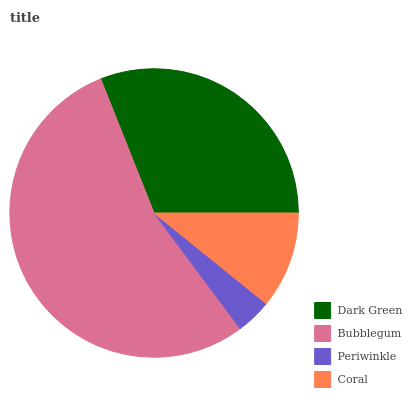Is Periwinkle the minimum?
Answer yes or no. Yes. Is Bubblegum the maximum?
Answer yes or no. Yes. Is Bubblegum the minimum?
Answer yes or no. No. Is Periwinkle the maximum?
Answer yes or no. No. Is Bubblegum greater than Periwinkle?
Answer yes or no. Yes. Is Periwinkle less than Bubblegum?
Answer yes or no. Yes. Is Periwinkle greater than Bubblegum?
Answer yes or no. No. Is Bubblegum less than Periwinkle?
Answer yes or no. No. Is Dark Green the high median?
Answer yes or no. Yes. Is Coral the low median?
Answer yes or no. Yes. Is Periwinkle the high median?
Answer yes or no. No. Is Bubblegum the low median?
Answer yes or no. No. 